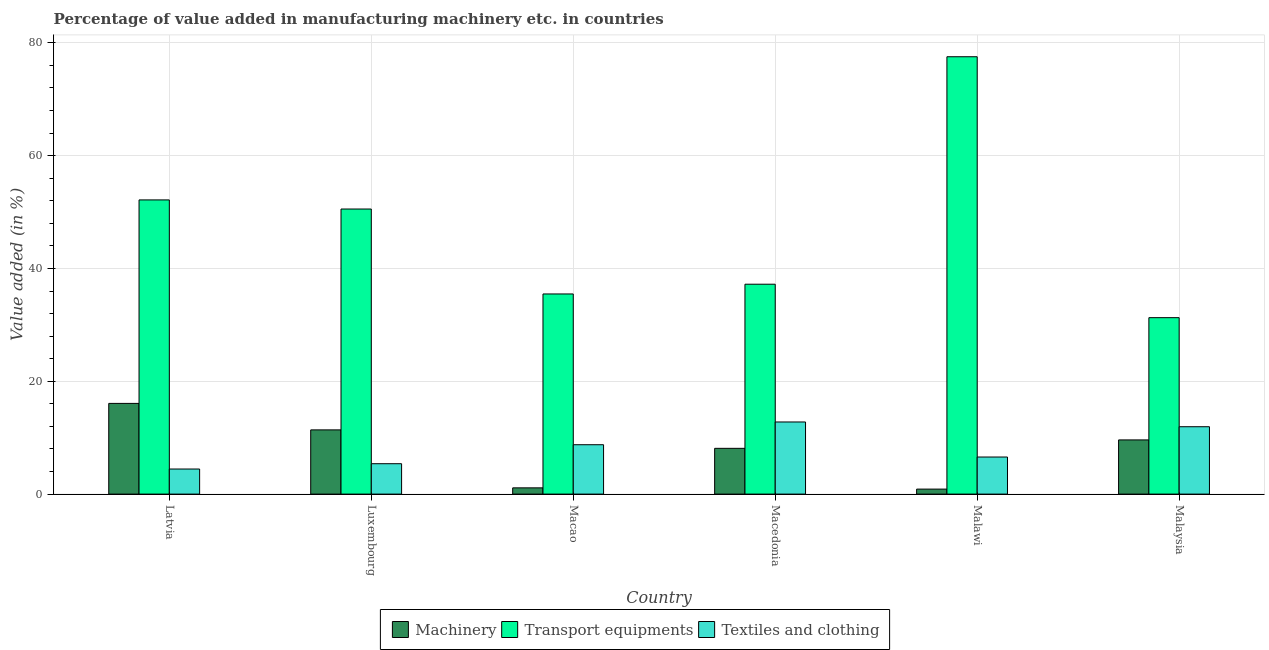How many different coloured bars are there?
Your response must be concise. 3. How many groups of bars are there?
Ensure brevity in your answer.  6. Are the number of bars on each tick of the X-axis equal?
Keep it short and to the point. Yes. What is the label of the 3rd group of bars from the left?
Ensure brevity in your answer.  Macao. What is the value added in manufacturing textile and clothing in Malawi?
Offer a terse response. 6.57. Across all countries, what is the maximum value added in manufacturing transport equipments?
Keep it short and to the point. 77.53. Across all countries, what is the minimum value added in manufacturing textile and clothing?
Your answer should be compact. 4.45. In which country was the value added in manufacturing textile and clothing maximum?
Ensure brevity in your answer.  Macedonia. In which country was the value added in manufacturing textile and clothing minimum?
Offer a terse response. Latvia. What is the total value added in manufacturing transport equipments in the graph?
Ensure brevity in your answer.  284.17. What is the difference between the value added in manufacturing machinery in Luxembourg and that in Macedonia?
Offer a terse response. 3.27. What is the difference between the value added in manufacturing transport equipments in Malawi and the value added in manufacturing textile and clothing in Latvia?
Ensure brevity in your answer.  73.08. What is the average value added in manufacturing transport equipments per country?
Your answer should be compact. 47.36. What is the difference between the value added in manufacturing textile and clothing and value added in manufacturing machinery in Luxembourg?
Your response must be concise. -5.99. In how many countries, is the value added in manufacturing machinery greater than 20 %?
Your answer should be very brief. 0. What is the ratio of the value added in manufacturing textile and clothing in Macedonia to that in Malaysia?
Your answer should be very brief. 1.07. Is the difference between the value added in manufacturing textile and clothing in Latvia and Macao greater than the difference between the value added in manufacturing machinery in Latvia and Macao?
Provide a short and direct response. No. What is the difference between the highest and the second highest value added in manufacturing textile and clothing?
Your answer should be compact. 0.84. What is the difference between the highest and the lowest value added in manufacturing machinery?
Offer a very short reply. 15.19. In how many countries, is the value added in manufacturing machinery greater than the average value added in manufacturing machinery taken over all countries?
Make the answer very short. 4. What does the 3rd bar from the left in Malawi represents?
Give a very brief answer. Textiles and clothing. What does the 3rd bar from the right in Latvia represents?
Your answer should be compact. Machinery. What is the difference between two consecutive major ticks on the Y-axis?
Make the answer very short. 20. Are the values on the major ticks of Y-axis written in scientific E-notation?
Give a very brief answer. No. Does the graph contain any zero values?
Your answer should be very brief. No. Where does the legend appear in the graph?
Your response must be concise. Bottom center. What is the title of the graph?
Give a very brief answer. Percentage of value added in manufacturing machinery etc. in countries. What is the label or title of the Y-axis?
Give a very brief answer. Value added (in %). What is the Value added (in %) in Machinery in Latvia?
Ensure brevity in your answer.  16.08. What is the Value added (in %) of Transport equipments in Latvia?
Make the answer very short. 52.15. What is the Value added (in %) in Textiles and clothing in Latvia?
Give a very brief answer. 4.45. What is the Value added (in %) in Machinery in Luxembourg?
Your answer should be compact. 11.38. What is the Value added (in %) of Transport equipments in Luxembourg?
Offer a terse response. 50.53. What is the Value added (in %) in Textiles and clothing in Luxembourg?
Make the answer very short. 5.39. What is the Value added (in %) in Machinery in Macao?
Your answer should be very brief. 1.11. What is the Value added (in %) of Transport equipments in Macao?
Your response must be concise. 35.48. What is the Value added (in %) in Textiles and clothing in Macao?
Make the answer very short. 8.75. What is the Value added (in %) in Machinery in Macedonia?
Offer a very short reply. 8.11. What is the Value added (in %) in Transport equipments in Macedonia?
Your answer should be compact. 37.21. What is the Value added (in %) of Textiles and clothing in Macedonia?
Provide a short and direct response. 12.79. What is the Value added (in %) in Machinery in Malawi?
Keep it short and to the point. 0.89. What is the Value added (in %) of Transport equipments in Malawi?
Provide a short and direct response. 77.53. What is the Value added (in %) in Textiles and clothing in Malawi?
Your response must be concise. 6.57. What is the Value added (in %) of Machinery in Malaysia?
Make the answer very short. 9.6. What is the Value added (in %) in Transport equipments in Malaysia?
Ensure brevity in your answer.  31.28. What is the Value added (in %) of Textiles and clothing in Malaysia?
Your answer should be very brief. 11.94. Across all countries, what is the maximum Value added (in %) of Machinery?
Provide a short and direct response. 16.08. Across all countries, what is the maximum Value added (in %) in Transport equipments?
Offer a very short reply. 77.53. Across all countries, what is the maximum Value added (in %) of Textiles and clothing?
Give a very brief answer. 12.79. Across all countries, what is the minimum Value added (in %) of Machinery?
Give a very brief answer. 0.89. Across all countries, what is the minimum Value added (in %) of Transport equipments?
Ensure brevity in your answer.  31.28. Across all countries, what is the minimum Value added (in %) in Textiles and clothing?
Your response must be concise. 4.45. What is the total Value added (in %) in Machinery in the graph?
Provide a short and direct response. 47.17. What is the total Value added (in %) of Transport equipments in the graph?
Your answer should be compact. 284.17. What is the total Value added (in %) of Textiles and clothing in the graph?
Make the answer very short. 49.89. What is the difference between the Value added (in %) of Machinery in Latvia and that in Luxembourg?
Keep it short and to the point. 4.69. What is the difference between the Value added (in %) of Transport equipments in Latvia and that in Luxembourg?
Provide a succinct answer. 1.62. What is the difference between the Value added (in %) of Textiles and clothing in Latvia and that in Luxembourg?
Keep it short and to the point. -0.94. What is the difference between the Value added (in %) in Machinery in Latvia and that in Macao?
Your answer should be very brief. 14.97. What is the difference between the Value added (in %) of Transport equipments in Latvia and that in Macao?
Provide a short and direct response. 16.67. What is the difference between the Value added (in %) in Textiles and clothing in Latvia and that in Macao?
Offer a terse response. -4.31. What is the difference between the Value added (in %) of Machinery in Latvia and that in Macedonia?
Offer a very short reply. 7.96. What is the difference between the Value added (in %) of Transport equipments in Latvia and that in Macedonia?
Provide a short and direct response. 14.94. What is the difference between the Value added (in %) of Textiles and clothing in Latvia and that in Macedonia?
Your answer should be compact. -8.34. What is the difference between the Value added (in %) of Machinery in Latvia and that in Malawi?
Your response must be concise. 15.19. What is the difference between the Value added (in %) in Transport equipments in Latvia and that in Malawi?
Give a very brief answer. -25.38. What is the difference between the Value added (in %) of Textiles and clothing in Latvia and that in Malawi?
Provide a short and direct response. -2.13. What is the difference between the Value added (in %) in Machinery in Latvia and that in Malaysia?
Provide a succinct answer. 6.47. What is the difference between the Value added (in %) in Transport equipments in Latvia and that in Malaysia?
Offer a terse response. 20.87. What is the difference between the Value added (in %) in Textiles and clothing in Latvia and that in Malaysia?
Provide a succinct answer. -7.5. What is the difference between the Value added (in %) of Machinery in Luxembourg and that in Macao?
Make the answer very short. 10.27. What is the difference between the Value added (in %) of Transport equipments in Luxembourg and that in Macao?
Offer a terse response. 15.06. What is the difference between the Value added (in %) in Textiles and clothing in Luxembourg and that in Macao?
Give a very brief answer. -3.37. What is the difference between the Value added (in %) in Machinery in Luxembourg and that in Macedonia?
Provide a succinct answer. 3.27. What is the difference between the Value added (in %) of Transport equipments in Luxembourg and that in Macedonia?
Offer a terse response. 13.33. What is the difference between the Value added (in %) in Textiles and clothing in Luxembourg and that in Macedonia?
Provide a short and direct response. -7.4. What is the difference between the Value added (in %) in Machinery in Luxembourg and that in Malawi?
Give a very brief answer. 10.5. What is the difference between the Value added (in %) in Transport equipments in Luxembourg and that in Malawi?
Give a very brief answer. -26.99. What is the difference between the Value added (in %) in Textiles and clothing in Luxembourg and that in Malawi?
Make the answer very short. -1.18. What is the difference between the Value added (in %) of Machinery in Luxembourg and that in Malaysia?
Ensure brevity in your answer.  1.78. What is the difference between the Value added (in %) of Transport equipments in Luxembourg and that in Malaysia?
Ensure brevity in your answer.  19.26. What is the difference between the Value added (in %) of Textiles and clothing in Luxembourg and that in Malaysia?
Keep it short and to the point. -6.56. What is the difference between the Value added (in %) in Machinery in Macao and that in Macedonia?
Provide a short and direct response. -7. What is the difference between the Value added (in %) of Transport equipments in Macao and that in Macedonia?
Keep it short and to the point. -1.73. What is the difference between the Value added (in %) of Textiles and clothing in Macao and that in Macedonia?
Make the answer very short. -4.03. What is the difference between the Value added (in %) of Machinery in Macao and that in Malawi?
Ensure brevity in your answer.  0.22. What is the difference between the Value added (in %) of Transport equipments in Macao and that in Malawi?
Offer a terse response. -42.05. What is the difference between the Value added (in %) of Textiles and clothing in Macao and that in Malawi?
Offer a terse response. 2.18. What is the difference between the Value added (in %) of Machinery in Macao and that in Malaysia?
Your response must be concise. -8.5. What is the difference between the Value added (in %) of Transport equipments in Macao and that in Malaysia?
Give a very brief answer. 4.2. What is the difference between the Value added (in %) in Textiles and clothing in Macao and that in Malaysia?
Provide a short and direct response. -3.19. What is the difference between the Value added (in %) in Machinery in Macedonia and that in Malawi?
Offer a very short reply. 7.23. What is the difference between the Value added (in %) of Transport equipments in Macedonia and that in Malawi?
Make the answer very short. -40.32. What is the difference between the Value added (in %) of Textiles and clothing in Macedonia and that in Malawi?
Offer a terse response. 6.21. What is the difference between the Value added (in %) of Machinery in Macedonia and that in Malaysia?
Provide a succinct answer. -1.49. What is the difference between the Value added (in %) in Transport equipments in Macedonia and that in Malaysia?
Make the answer very short. 5.93. What is the difference between the Value added (in %) of Textiles and clothing in Macedonia and that in Malaysia?
Your response must be concise. 0.84. What is the difference between the Value added (in %) of Machinery in Malawi and that in Malaysia?
Give a very brief answer. -8.72. What is the difference between the Value added (in %) of Transport equipments in Malawi and that in Malaysia?
Offer a terse response. 46.25. What is the difference between the Value added (in %) in Textiles and clothing in Malawi and that in Malaysia?
Your response must be concise. -5.37. What is the difference between the Value added (in %) of Machinery in Latvia and the Value added (in %) of Transport equipments in Luxembourg?
Provide a succinct answer. -34.46. What is the difference between the Value added (in %) of Machinery in Latvia and the Value added (in %) of Textiles and clothing in Luxembourg?
Give a very brief answer. 10.69. What is the difference between the Value added (in %) in Transport equipments in Latvia and the Value added (in %) in Textiles and clothing in Luxembourg?
Offer a very short reply. 46.76. What is the difference between the Value added (in %) in Machinery in Latvia and the Value added (in %) in Transport equipments in Macao?
Provide a short and direct response. -19.4. What is the difference between the Value added (in %) of Machinery in Latvia and the Value added (in %) of Textiles and clothing in Macao?
Give a very brief answer. 7.32. What is the difference between the Value added (in %) in Transport equipments in Latvia and the Value added (in %) in Textiles and clothing in Macao?
Provide a short and direct response. 43.4. What is the difference between the Value added (in %) of Machinery in Latvia and the Value added (in %) of Transport equipments in Macedonia?
Make the answer very short. -21.13. What is the difference between the Value added (in %) in Machinery in Latvia and the Value added (in %) in Textiles and clothing in Macedonia?
Your answer should be very brief. 3.29. What is the difference between the Value added (in %) of Transport equipments in Latvia and the Value added (in %) of Textiles and clothing in Macedonia?
Ensure brevity in your answer.  39.36. What is the difference between the Value added (in %) in Machinery in Latvia and the Value added (in %) in Transport equipments in Malawi?
Your answer should be very brief. -61.45. What is the difference between the Value added (in %) in Machinery in Latvia and the Value added (in %) in Textiles and clothing in Malawi?
Give a very brief answer. 9.51. What is the difference between the Value added (in %) in Transport equipments in Latvia and the Value added (in %) in Textiles and clothing in Malawi?
Make the answer very short. 45.58. What is the difference between the Value added (in %) in Machinery in Latvia and the Value added (in %) in Transport equipments in Malaysia?
Ensure brevity in your answer.  -15.2. What is the difference between the Value added (in %) in Machinery in Latvia and the Value added (in %) in Textiles and clothing in Malaysia?
Offer a very short reply. 4.13. What is the difference between the Value added (in %) in Transport equipments in Latvia and the Value added (in %) in Textiles and clothing in Malaysia?
Provide a succinct answer. 40.21. What is the difference between the Value added (in %) of Machinery in Luxembourg and the Value added (in %) of Transport equipments in Macao?
Your answer should be very brief. -24.09. What is the difference between the Value added (in %) of Machinery in Luxembourg and the Value added (in %) of Textiles and clothing in Macao?
Ensure brevity in your answer.  2.63. What is the difference between the Value added (in %) of Transport equipments in Luxembourg and the Value added (in %) of Textiles and clothing in Macao?
Provide a succinct answer. 41.78. What is the difference between the Value added (in %) in Machinery in Luxembourg and the Value added (in %) in Transport equipments in Macedonia?
Keep it short and to the point. -25.82. What is the difference between the Value added (in %) in Machinery in Luxembourg and the Value added (in %) in Textiles and clothing in Macedonia?
Ensure brevity in your answer.  -1.4. What is the difference between the Value added (in %) of Transport equipments in Luxembourg and the Value added (in %) of Textiles and clothing in Macedonia?
Provide a short and direct response. 37.75. What is the difference between the Value added (in %) of Machinery in Luxembourg and the Value added (in %) of Transport equipments in Malawi?
Offer a very short reply. -66.14. What is the difference between the Value added (in %) of Machinery in Luxembourg and the Value added (in %) of Textiles and clothing in Malawi?
Your answer should be very brief. 4.81. What is the difference between the Value added (in %) in Transport equipments in Luxembourg and the Value added (in %) in Textiles and clothing in Malawi?
Make the answer very short. 43.96. What is the difference between the Value added (in %) in Machinery in Luxembourg and the Value added (in %) in Transport equipments in Malaysia?
Your response must be concise. -19.89. What is the difference between the Value added (in %) in Machinery in Luxembourg and the Value added (in %) in Textiles and clothing in Malaysia?
Provide a short and direct response. -0.56. What is the difference between the Value added (in %) of Transport equipments in Luxembourg and the Value added (in %) of Textiles and clothing in Malaysia?
Your response must be concise. 38.59. What is the difference between the Value added (in %) in Machinery in Macao and the Value added (in %) in Transport equipments in Macedonia?
Make the answer very short. -36.1. What is the difference between the Value added (in %) in Machinery in Macao and the Value added (in %) in Textiles and clothing in Macedonia?
Give a very brief answer. -11.68. What is the difference between the Value added (in %) in Transport equipments in Macao and the Value added (in %) in Textiles and clothing in Macedonia?
Give a very brief answer. 22.69. What is the difference between the Value added (in %) in Machinery in Macao and the Value added (in %) in Transport equipments in Malawi?
Make the answer very short. -76.42. What is the difference between the Value added (in %) of Machinery in Macao and the Value added (in %) of Textiles and clothing in Malawi?
Offer a very short reply. -5.46. What is the difference between the Value added (in %) in Transport equipments in Macao and the Value added (in %) in Textiles and clothing in Malawi?
Your response must be concise. 28.91. What is the difference between the Value added (in %) of Machinery in Macao and the Value added (in %) of Transport equipments in Malaysia?
Ensure brevity in your answer.  -30.17. What is the difference between the Value added (in %) of Machinery in Macao and the Value added (in %) of Textiles and clothing in Malaysia?
Give a very brief answer. -10.83. What is the difference between the Value added (in %) of Transport equipments in Macao and the Value added (in %) of Textiles and clothing in Malaysia?
Provide a succinct answer. 23.53. What is the difference between the Value added (in %) in Machinery in Macedonia and the Value added (in %) in Transport equipments in Malawi?
Ensure brevity in your answer.  -69.41. What is the difference between the Value added (in %) of Machinery in Macedonia and the Value added (in %) of Textiles and clothing in Malawi?
Your response must be concise. 1.54. What is the difference between the Value added (in %) in Transport equipments in Macedonia and the Value added (in %) in Textiles and clothing in Malawi?
Offer a terse response. 30.63. What is the difference between the Value added (in %) in Machinery in Macedonia and the Value added (in %) in Transport equipments in Malaysia?
Provide a short and direct response. -23.16. What is the difference between the Value added (in %) in Machinery in Macedonia and the Value added (in %) in Textiles and clothing in Malaysia?
Provide a succinct answer. -3.83. What is the difference between the Value added (in %) of Transport equipments in Macedonia and the Value added (in %) of Textiles and clothing in Malaysia?
Your response must be concise. 25.26. What is the difference between the Value added (in %) of Machinery in Malawi and the Value added (in %) of Transport equipments in Malaysia?
Give a very brief answer. -30.39. What is the difference between the Value added (in %) in Machinery in Malawi and the Value added (in %) in Textiles and clothing in Malaysia?
Your answer should be very brief. -11.06. What is the difference between the Value added (in %) of Transport equipments in Malawi and the Value added (in %) of Textiles and clothing in Malaysia?
Your answer should be compact. 65.58. What is the average Value added (in %) in Machinery per country?
Ensure brevity in your answer.  7.86. What is the average Value added (in %) of Transport equipments per country?
Ensure brevity in your answer.  47.36. What is the average Value added (in %) in Textiles and clothing per country?
Ensure brevity in your answer.  8.31. What is the difference between the Value added (in %) of Machinery and Value added (in %) of Transport equipments in Latvia?
Provide a succinct answer. -36.07. What is the difference between the Value added (in %) of Machinery and Value added (in %) of Textiles and clothing in Latvia?
Your answer should be compact. 11.63. What is the difference between the Value added (in %) in Transport equipments and Value added (in %) in Textiles and clothing in Latvia?
Ensure brevity in your answer.  47.7. What is the difference between the Value added (in %) in Machinery and Value added (in %) in Transport equipments in Luxembourg?
Offer a very short reply. -39.15. What is the difference between the Value added (in %) of Machinery and Value added (in %) of Textiles and clothing in Luxembourg?
Offer a very short reply. 5.99. What is the difference between the Value added (in %) of Transport equipments and Value added (in %) of Textiles and clothing in Luxembourg?
Offer a terse response. 45.15. What is the difference between the Value added (in %) of Machinery and Value added (in %) of Transport equipments in Macao?
Provide a succinct answer. -34.37. What is the difference between the Value added (in %) in Machinery and Value added (in %) in Textiles and clothing in Macao?
Provide a short and direct response. -7.64. What is the difference between the Value added (in %) of Transport equipments and Value added (in %) of Textiles and clothing in Macao?
Provide a short and direct response. 26.72. What is the difference between the Value added (in %) in Machinery and Value added (in %) in Transport equipments in Macedonia?
Offer a terse response. -29.09. What is the difference between the Value added (in %) in Machinery and Value added (in %) in Textiles and clothing in Macedonia?
Your response must be concise. -4.67. What is the difference between the Value added (in %) of Transport equipments and Value added (in %) of Textiles and clothing in Macedonia?
Give a very brief answer. 24.42. What is the difference between the Value added (in %) of Machinery and Value added (in %) of Transport equipments in Malawi?
Your answer should be compact. -76.64. What is the difference between the Value added (in %) of Machinery and Value added (in %) of Textiles and clothing in Malawi?
Your answer should be compact. -5.68. What is the difference between the Value added (in %) in Transport equipments and Value added (in %) in Textiles and clothing in Malawi?
Make the answer very short. 70.95. What is the difference between the Value added (in %) of Machinery and Value added (in %) of Transport equipments in Malaysia?
Ensure brevity in your answer.  -21.67. What is the difference between the Value added (in %) of Machinery and Value added (in %) of Textiles and clothing in Malaysia?
Offer a very short reply. -2.34. What is the difference between the Value added (in %) in Transport equipments and Value added (in %) in Textiles and clothing in Malaysia?
Your answer should be very brief. 19.33. What is the ratio of the Value added (in %) in Machinery in Latvia to that in Luxembourg?
Your answer should be compact. 1.41. What is the ratio of the Value added (in %) of Transport equipments in Latvia to that in Luxembourg?
Your answer should be compact. 1.03. What is the ratio of the Value added (in %) in Textiles and clothing in Latvia to that in Luxembourg?
Your response must be concise. 0.83. What is the ratio of the Value added (in %) of Machinery in Latvia to that in Macao?
Your answer should be compact. 14.5. What is the ratio of the Value added (in %) of Transport equipments in Latvia to that in Macao?
Offer a terse response. 1.47. What is the ratio of the Value added (in %) in Textiles and clothing in Latvia to that in Macao?
Offer a very short reply. 0.51. What is the ratio of the Value added (in %) in Machinery in Latvia to that in Macedonia?
Offer a terse response. 1.98. What is the ratio of the Value added (in %) of Transport equipments in Latvia to that in Macedonia?
Your answer should be very brief. 1.4. What is the ratio of the Value added (in %) of Textiles and clothing in Latvia to that in Macedonia?
Your answer should be very brief. 0.35. What is the ratio of the Value added (in %) in Machinery in Latvia to that in Malawi?
Your response must be concise. 18.13. What is the ratio of the Value added (in %) of Transport equipments in Latvia to that in Malawi?
Offer a terse response. 0.67. What is the ratio of the Value added (in %) of Textiles and clothing in Latvia to that in Malawi?
Make the answer very short. 0.68. What is the ratio of the Value added (in %) of Machinery in Latvia to that in Malaysia?
Ensure brevity in your answer.  1.67. What is the ratio of the Value added (in %) in Transport equipments in Latvia to that in Malaysia?
Offer a terse response. 1.67. What is the ratio of the Value added (in %) of Textiles and clothing in Latvia to that in Malaysia?
Make the answer very short. 0.37. What is the ratio of the Value added (in %) in Machinery in Luxembourg to that in Macao?
Keep it short and to the point. 10.27. What is the ratio of the Value added (in %) in Transport equipments in Luxembourg to that in Macao?
Keep it short and to the point. 1.42. What is the ratio of the Value added (in %) of Textiles and clothing in Luxembourg to that in Macao?
Give a very brief answer. 0.62. What is the ratio of the Value added (in %) of Machinery in Luxembourg to that in Macedonia?
Your answer should be compact. 1.4. What is the ratio of the Value added (in %) in Transport equipments in Luxembourg to that in Macedonia?
Give a very brief answer. 1.36. What is the ratio of the Value added (in %) in Textiles and clothing in Luxembourg to that in Macedonia?
Offer a very short reply. 0.42. What is the ratio of the Value added (in %) of Machinery in Luxembourg to that in Malawi?
Give a very brief answer. 12.84. What is the ratio of the Value added (in %) of Transport equipments in Luxembourg to that in Malawi?
Ensure brevity in your answer.  0.65. What is the ratio of the Value added (in %) in Textiles and clothing in Luxembourg to that in Malawi?
Provide a succinct answer. 0.82. What is the ratio of the Value added (in %) in Machinery in Luxembourg to that in Malaysia?
Give a very brief answer. 1.19. What is the ratio of the Value added (in %) of Transport equipments in Luxembourg to that in Malaysia?
Make the answer very short. 1.62. What is the ratio of the Value added (in %) in Textiles and clothing in Luxembourg to that in Malaysia?
Give a very brief answer. 0.45. What is the ratio of the Value added (in %) in Machinery in Macao to that in Macedonia?
Make the answer very short. 0.14. What is the ratio of the Value added (in %) in Transport equipments in Macao to that in Macedonia?
Your response must be concise. 0.95. What is the ratio of the Value added (in %) of Textiles and clothing in Macao to that in Macedonia?
Your answer should be compact. 0.68. What is the ratio of the Value added (in %) of Machinery in Macao to that in Malawi?
Your response must be concise. 1.25. What is the ratio of the Value added (in %) in Transport equipments in Macao to that in Malawi?
Offer a very short reply. 0.46. What is the ratio of the Value added (in %) in Textiles and clothing in Macao to that in Malawi?
Your response must be concise. 1.33. What is the ratio of the Value added (in %) of Machinery in Macao to that in Malaysia?
Provide a short and direct response. 0.12. What is the ratio of the Value added (in %) in Transport equipments in Macao to that in Malaysia?
Your answer should be very brief. 1.13. What is the ratio of the Value added (in %) in Textiles and clothing in Macao to that in Malaysia?
Make the answer very short. 0.73. What is the ratio of the Value added (in %) in Machinery in Macedonia to that in Malawi?
Provide a short and direct response. 9.15. What is the ratio of the Value added (in %) in Transport equipments in Macedonia to that in Malawi?
Keep it short and to the point. 0.48. What is the ratio of the Value added (in %) in Textiles and clothing in Macedonia to that in Malawi?
Make the answer very short. 1.95. What is the ratio of the Value added (in %) in Machinery in Macedonia to that in Malaysia?
Offer a terse response. 0.84. What is the ratio of the Value added (in %) of Transport equipments in Macedonia to that in Malaysia?
Your answer should be compact. 1.19. What is the ratio of the Value added (in %) in Textiles and clothing in Macedonia to that in Malaysia?
Keep it short and to the point. 1.07. What is the ratio of the Value added (in %) of Machinery in Malawi to that in Malaysia?
Provide a succinct answer. 0.09. What is the ratio of the Value added (in %) in Transport equipments in Malawi to that in Malaysia?
Ensure brevity in your answer.  2.48. What is the ratio of the Value added (in %) of Textiles and clothing in Malawi to that in Malaysia?
Ensure brevity in your answer.  0.55. What is the difference between the highest and the second highest Value added (in %) of Machinery?
Offer a very short reply. 4.69. What is the difference between the highest and the second highest Value added (in %) in Transport equipments?
Provide a short and direct response. 25.38. What is the difference between the highest and the second highest Value added (in %) in Textiles and clothing?
Provide a succinct answer. 0.84. What is the difference between the highest and the lowest Value added (in %) of Machinery?
Make the answer very short. 15.19. What is the difference between the highest and the lowest Value added (in %) of Transport equipments?
Provide a succinct answer. 46.25. What is the difference between the highest and the lowest Value added (in %) in Textiles and clothing?
Your response must be concise. 8.34. 